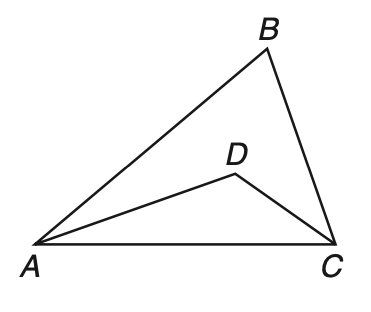Question: In \triangle A B C, A D and D C are angle bisectors and m \angle B = 76. What is the measure of \angle A D C?
Choices:
A. 26
B. 52
C. 76
D. 128
Answer with the letter. Answer: D 